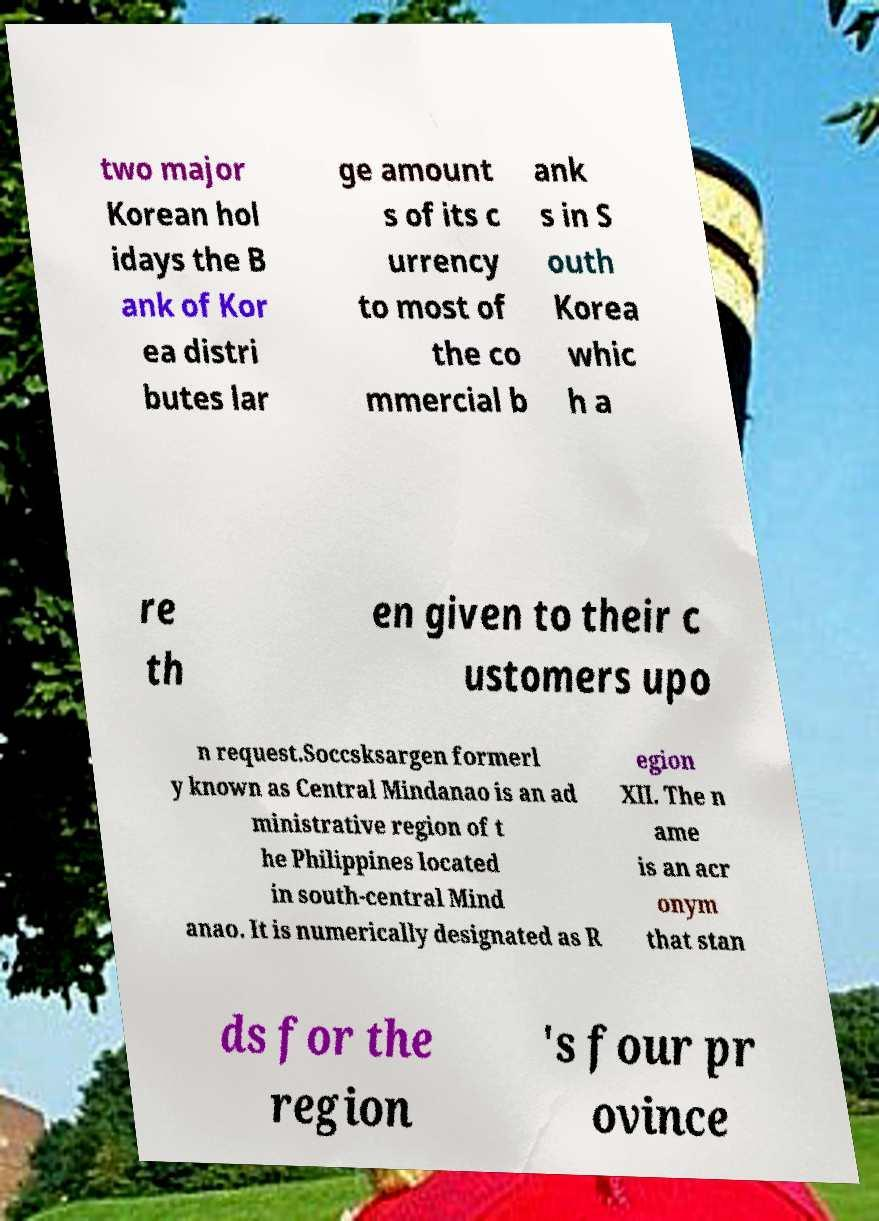For documentation purposes, I need the text within this image transcribed. Could you provide that? two major Korean hol idays the B ank of Kor ea distri butes lar ge amount s of its c urrency to most of the co mmercial b ank s in S outh Korea whic h a re th en given to their c ustomers upo n request.Soccsksargen formerl y known as Central Mindanao is an ad ministrative region of t he Philippines located in south-central Mind anao. It is numerically designated as R egion XII. The n ame is an acr onym that stan ds for the region 's four pr ovince 